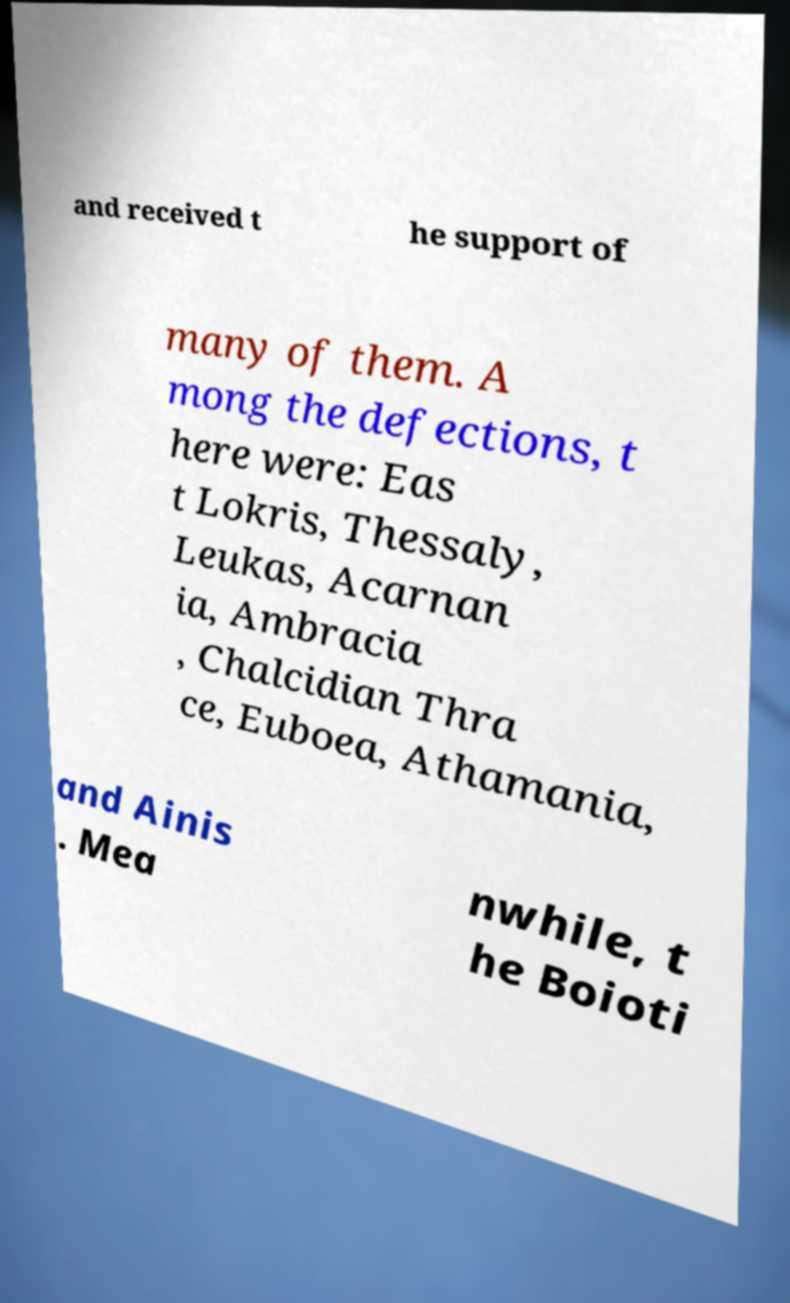There's text embedded in this image that I need extracted. Can you transcribe it verbatim? and received t he support of many of them. A mong the defections, t here were: Eas t Lokris, Thessaly, Leukas, Acarnan ia, Ambracia , Chalcidian Thra ce, Euboea, Athamania, and Ainis . Mea nwhile, t he Boioti 